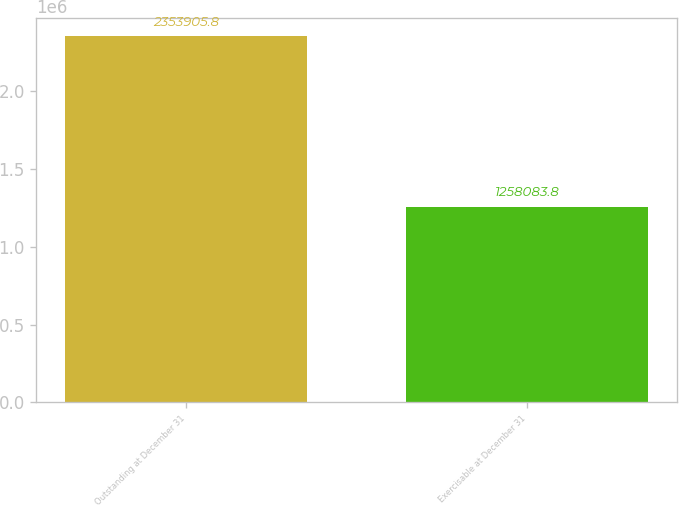Convert chart. <chart><loc_0><loc_0><loc_500><loc_500><bar_chart><fcel>Outstanding at December 31<fcel>Exercisable at December 31<nl><fcel>2.35391e+06<fcel>1.25808e+06<nl></chart> 